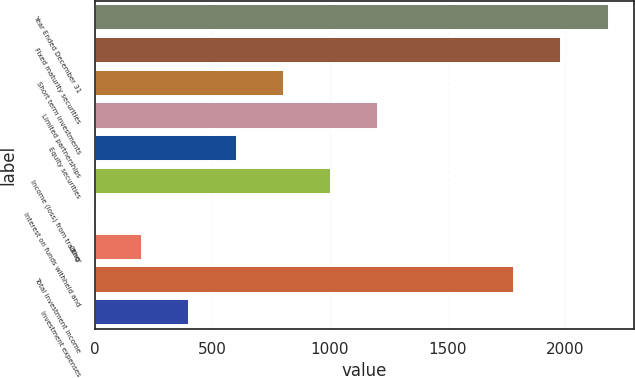<chart> <loc_0><loc_0><loc_500><loc_500><bar_chart><fcel>Year Ended December 31<fcel>Fixed maturity securities<fcel>Short term investments<fcel>Limited partnerships<fcel>Equity securities<fcel>Income (loss) from trading<fcel>Interest on funds withheld and<fcel>Other<fcel>Total investment income<fcel>Investment expenses<nl><fcel>2184.6<fcel>1984<fcel>804.4<fcel>1205.6<fcel>603.8<fcel>1005<fcel>2<fcel>202.6<fcel>1781.6<fcel>403.2<nl></chart> 